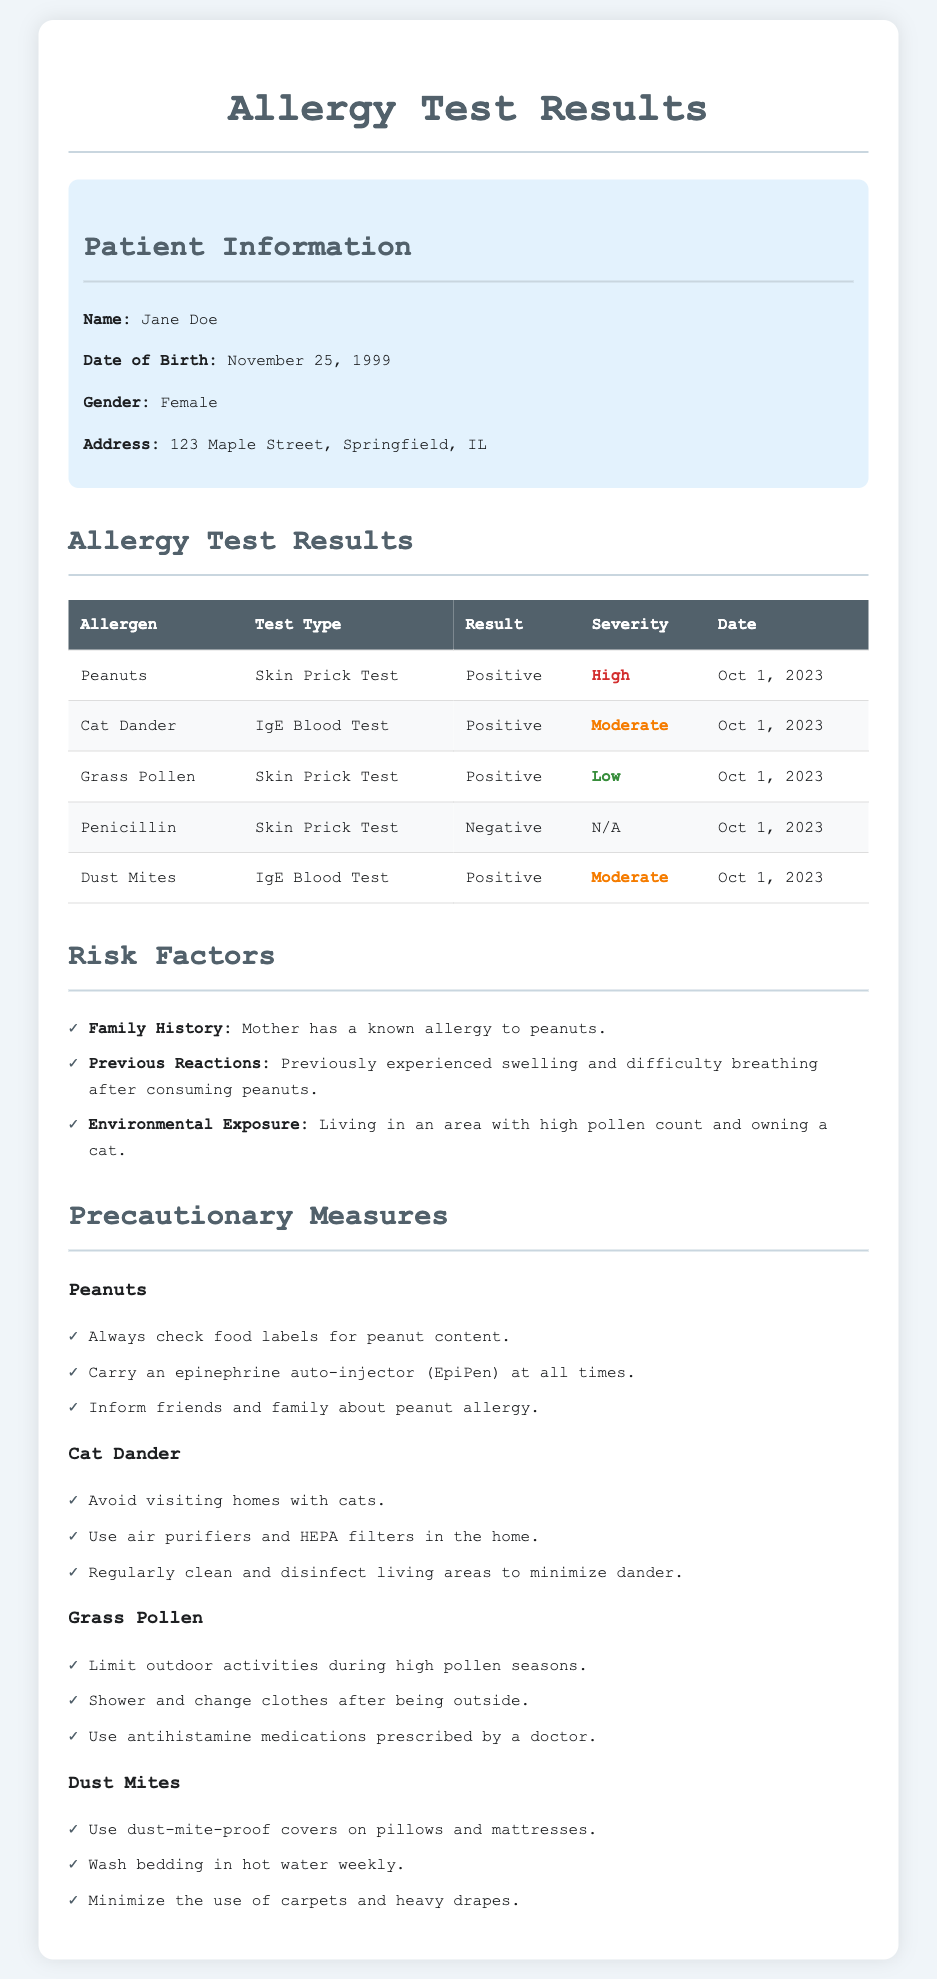What is the patient's name? The patient's name is mentioned in the patient information section.
Answer: Jane Doe What is the date of the allergy test? The date is listed in the results table under the Date column for each allergen tested.
Answer: Oct 1, 2023 Which allergen has a high severity level? The severity levels are indicated in the results table, and "High" is specified for peanuts.
Answer: Peanuts What previous reaction did the patient have? The document mentions a previous reaction in the risk factors section.
Answer: Swelling and difficulty breathing What precaution should be taken for cat dander? The precautionary measures for cat dander suggest actions to minimize exposure.
Answer: Avoid visiting homes with cats How many allergens tested positive? The table summarizes the test results for allergens and counts positive results.
Answer: Four What test type was used for grass pollen? The test type for grass pollen is listed in the allergy test results table.
Answer: Skin Prick Test Who in the family has a known allergy? The risk factors section identifies family members with allergies.
Answer: Mother What should be used for dust mites? Precautionary measures suggest specific actions regarding dust mites in the home.
Answer: Dust-mite-proof covers 